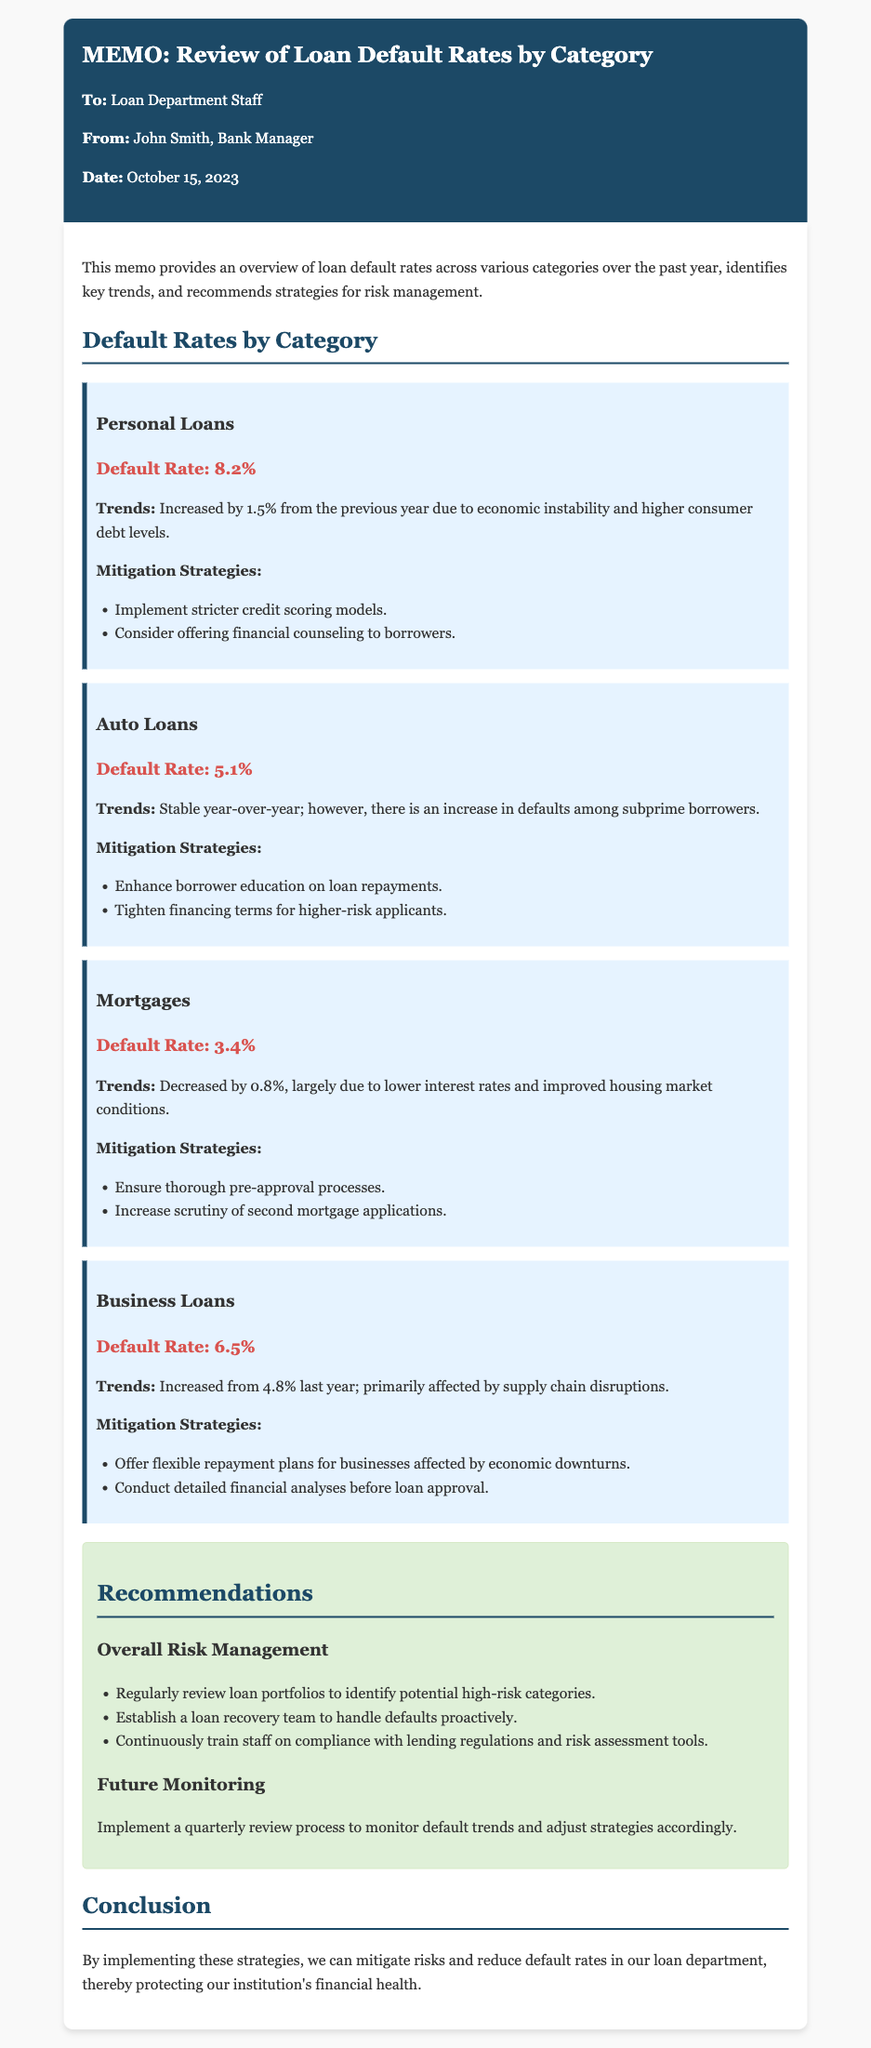What is the default rate for Personal Loans? The default rate for Personal Loans is presented in the document as 8.2%.
Answer: 8.2% What was the default rate for Business Loans last year? The document states that the default rate for Business Loans was 4.8% last year.
Answer: 4.8% What are the recommended strategies for Auto Loans? The memo lists "Enhance borrower education on loan repayments" and "Tighten financing terms for higher-risk applicants" as mitigation strategies for Auto Loans.
Answer: Enhance borrower education on loan repayments; Tighten financing terms for higher-risk applicants What is the total number of loan categories discussed in the memo? The memo describes four loan categories: Personal Loans, Auto Loans, Mortgages, and Business Loans.
Answer: Four Which loan category saw a decrease in default rate? The memo indicates that Mortgages saw a decrease in default rate.
Answer: Mortgages What is one recommendation for overall risk management? Among the recommendations for overall risk management, the memo suggests "Regularly review loan portfolios to identify potential high-risk categories."
Answer: Regularly review loan portfolios to identify potential high-risk categories What trend affected Business Loans default rates? The document mentions that Business Loans default rates were primarily affected by supply chain disruptions.
Answer: Supply chain disruptions On what date was the memo issued? The memo was issued on October 15, 2023.
Answer: October 15, 2023 